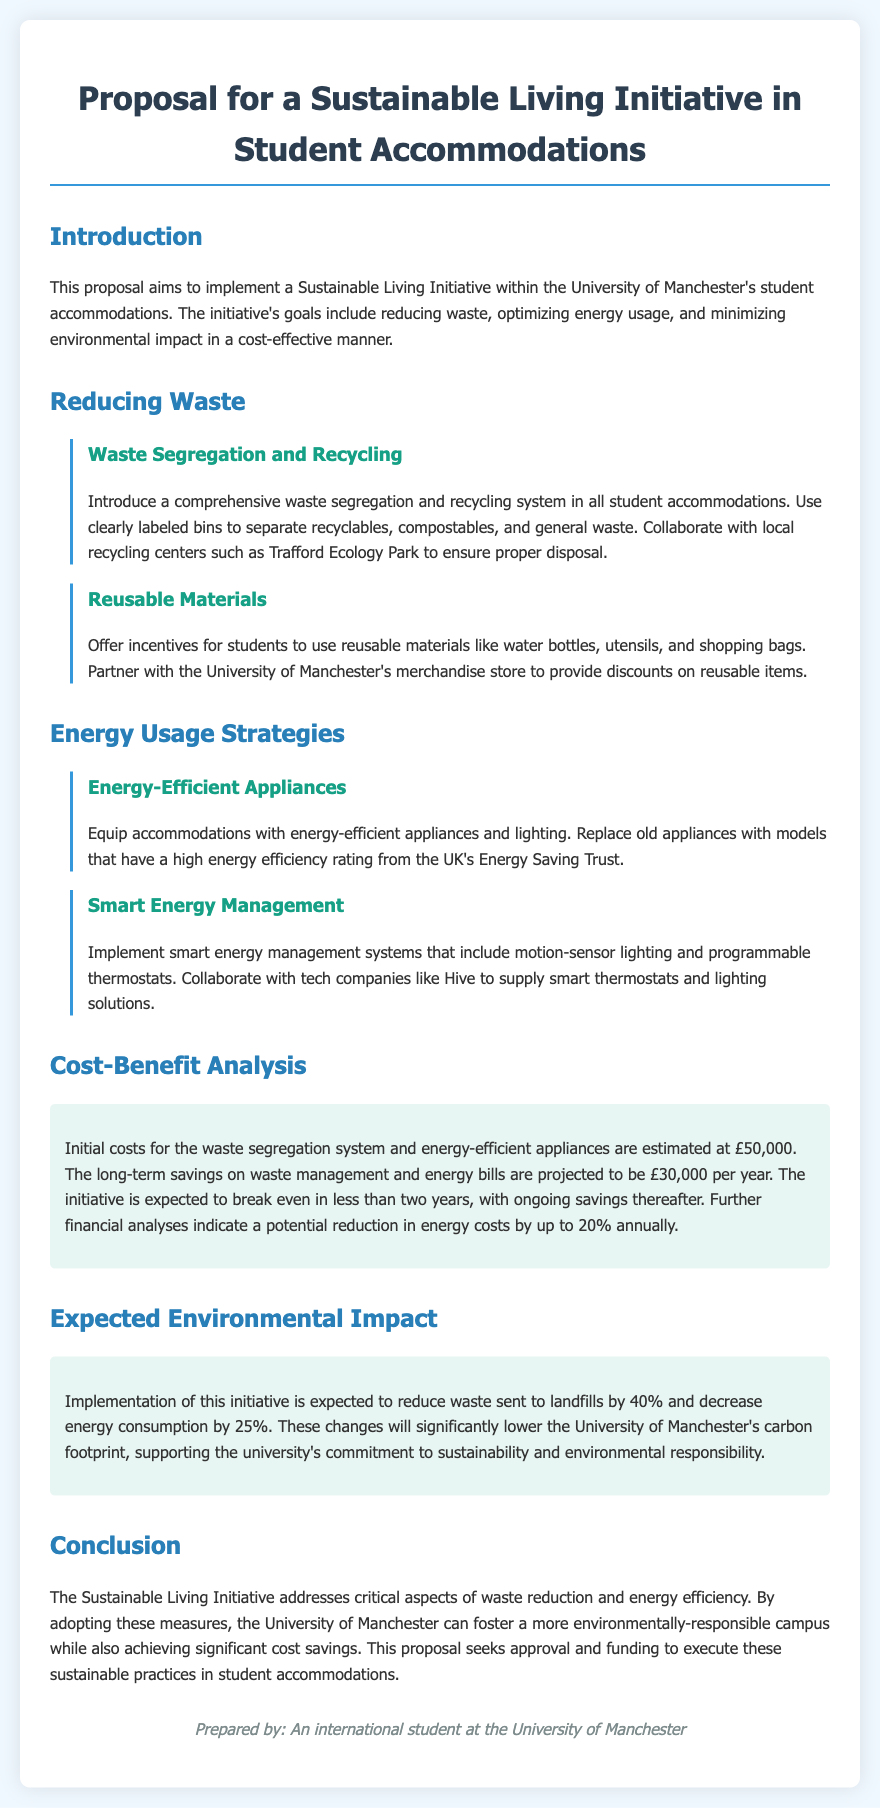What is the estimated initial cost of the initiative? The initial costs for the waste segregation system and energy-efficient appliances are detailed in the cost-benefit analysis section of the document.
Answer: £50,000 What is the expected annual reduction in energy costs? The document provides a projection on energy costs savings presented in the cost-benefit analysis.
Answer: up to 20% What is the proposed waste reduction percentage? The expected environmental impact section discusses the anticipated reduction in waste sent to landfills.
Answer: 40% Who is the proposal prepared by? The footer of the document states who has prepared the proposal.
Answer: An international student at the University of Manchester What type of appliances will be equipped in accommodations? The energy usage strategies section mentions the type of appliances to be introduced in student accommodations.
Answer: energy-efficient appliances What collaboration is suggested for waste disposal? The proposal mentions a collaboration for proper disposal of waste materials in the waste reduction section.
Answer: Trafford Ecology Park What is the expected decrease in energy consumption? The expected environmental impact section outlines the anticipated decrease in energy consumption percentages.
Answer: 25% Which company is suggested for supplying smart energy management systems? The energy usage strategies section includes a proposed collaboration with a tech company.
Answer: Hive 